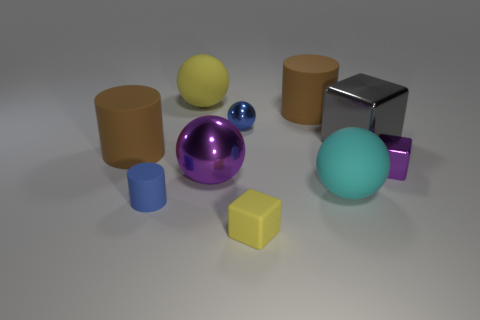Subtract all cylinders. How many objects are left? 7 Add 1 large cyan rubber objects. How many large cyan rubber objects are left? 2 Add 6 large cubes. How many large cubes exist? 7 Subtract 0 green cylinders. How many objects are left? 10 Subtract all tiny blue shiny objects. Subtract all tiny things. How many objects are left? 5 